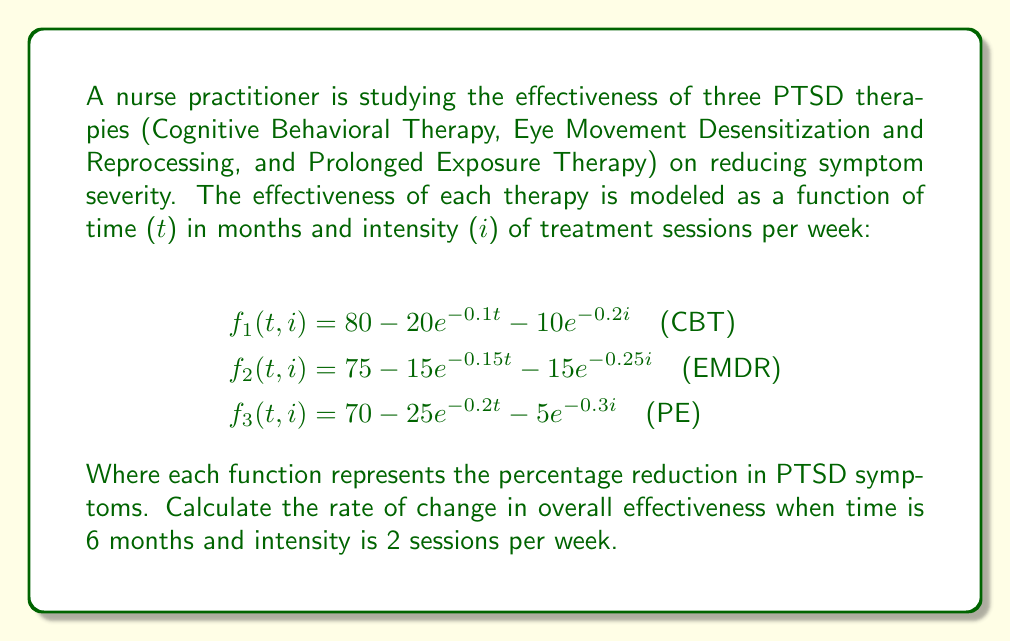Give your solution to this math problem. To solve this problem, we need to follow these steps:

1) First, we need to create a function that represents the overall effectiveness of all three therapies combined. We can do this by taking the average of the three functions:

   $$F(t,i) = \frac{f_1(t,i) + f_2(t,i) + f_3(t,i)}{3}$$

2) Now, we need to find the rate of change of this function with respect to both time and intensity. This is done by calculating the gradient of F(t,i):

   $$\nabla F(t,i) = \left(\frac{\partial F}{\partial t}, \frac{\partial F}{\partial i}\right)$$

3) Let's calculate these partial derivatives:

   $$\begin{align}
   \frac{\partial F}{\partial t} &= \frac{1}{3}\left(2e^{-0.1t} + 2.25e^{-0.15t} + 5e^{-0.2t}\right) \\
   \frac{\partial F}{\partial i} &= \frac{1}{3}\left(2e^{-0.2i} + 3.75e^{-0.25i} + 1.5e^{-0.3i}\right)
   \end{align}$$

4) Now, we need to evaluate these at t = 6 and i = 2:

   $$\begin{align}
   \left.\frac{\partial F}{\partial t}\right|_{(6,2)} &= \frac{1}{3}\left(2e^{-0.6} + 2.25e^{-0.9} + 5e^{-1.2}\right) \approx 0.7176 \\
   \left.\frac{\partial F}{\partial i}\right|_{(6,2)} &= \frac{1}{3}\left(2e^{-0.4} + 3.75e^{-0.5} + 1.5e^{-0.6}\right) \approx 0.9943
   \end{align}$$

5) The gradient at (6,2) is therefore:

   $$\nabla F(6,2) \approx (0.7176, 0.9943)$$

6) To find the overall rate of change, we calculate the magnitude of this vector:

   $$\|\nabla F(6,2)\| = \sqrt{(0.7176)^2 + (0.9943)^2} \approx 1.2267$$

Therefore, the rate of change in overall effectiveness when time is 6 months and intensity is 2 sessions per week is approximately 1.2267 percent per unit change in time and intensity.
Answer: 1.2267 percent per unit change 